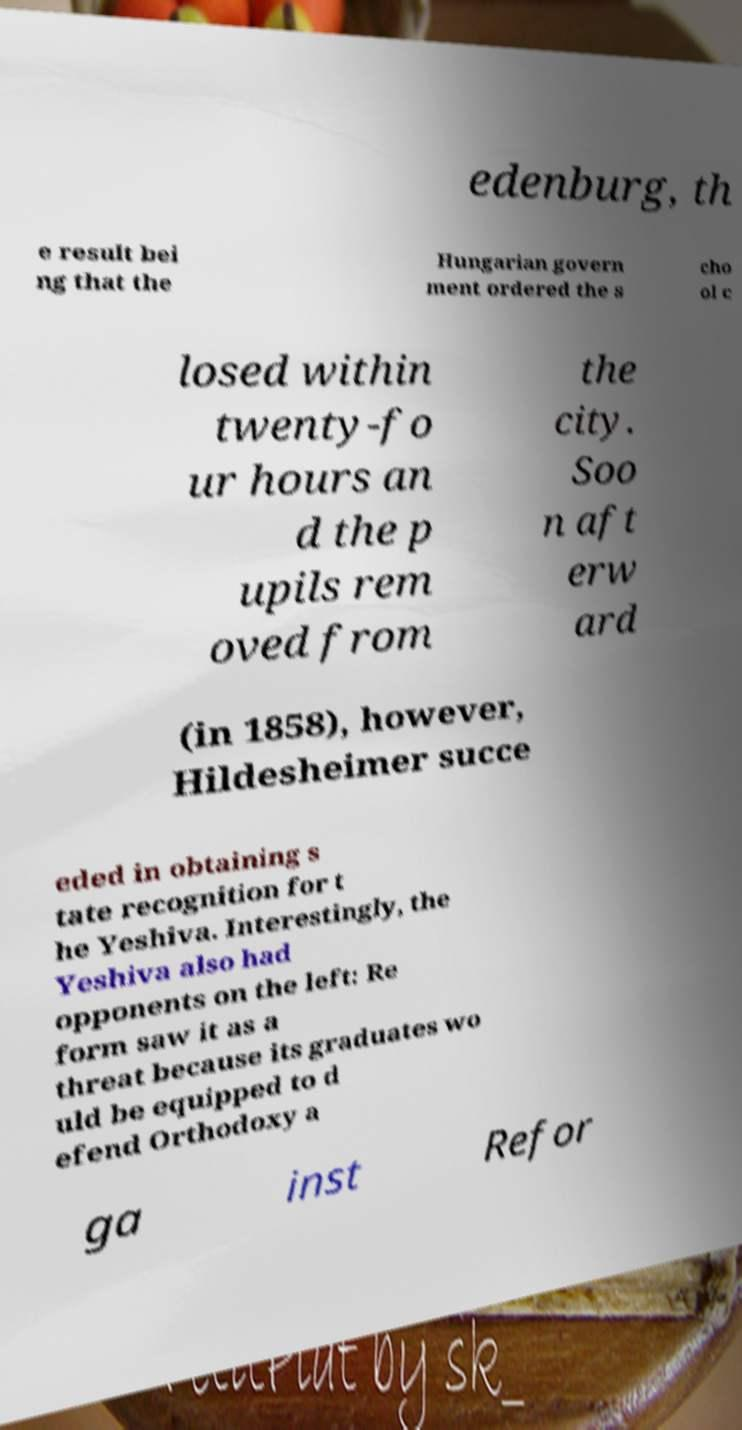For documentation purposes, I need the text within this image transcribed. Could you provide that? edenburg, th e result bei ng that the Hungarian govern ment ordered the s cho ol c losed within twenty-fo ur hours an d the p upils rem oved from the city. Soo n aft erw ard (in 1858), however, Hildesheimer succe eded in obtaining s tate recognition for t he Yeshiva. Interestingly, the Yeshiva also had opponents on the left: Re form saw it as a threat because its graduates wo uld be equipped to d efend Orthodoxy a ga inst Refor 